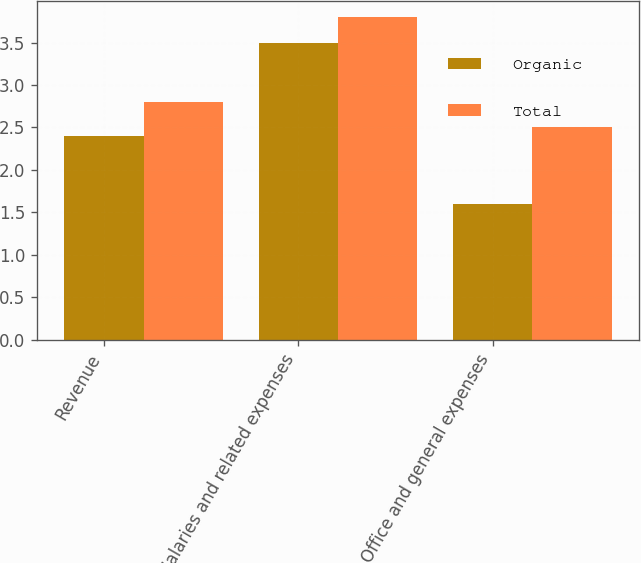<chart> <loc_0><loc_0><loc_500><loc_500><stacked_bar_chart><ecel><fcel>Revenue<fcel>Salaries and related expenses<fcel>Office and general expenses<nl><fcel>Organic<fcel>2.4<fcel>3.5<fcel>1.6<nl><fcel>Total<fcel>2.8<fcel>3.8<fcel>2.5<nl></chart> 